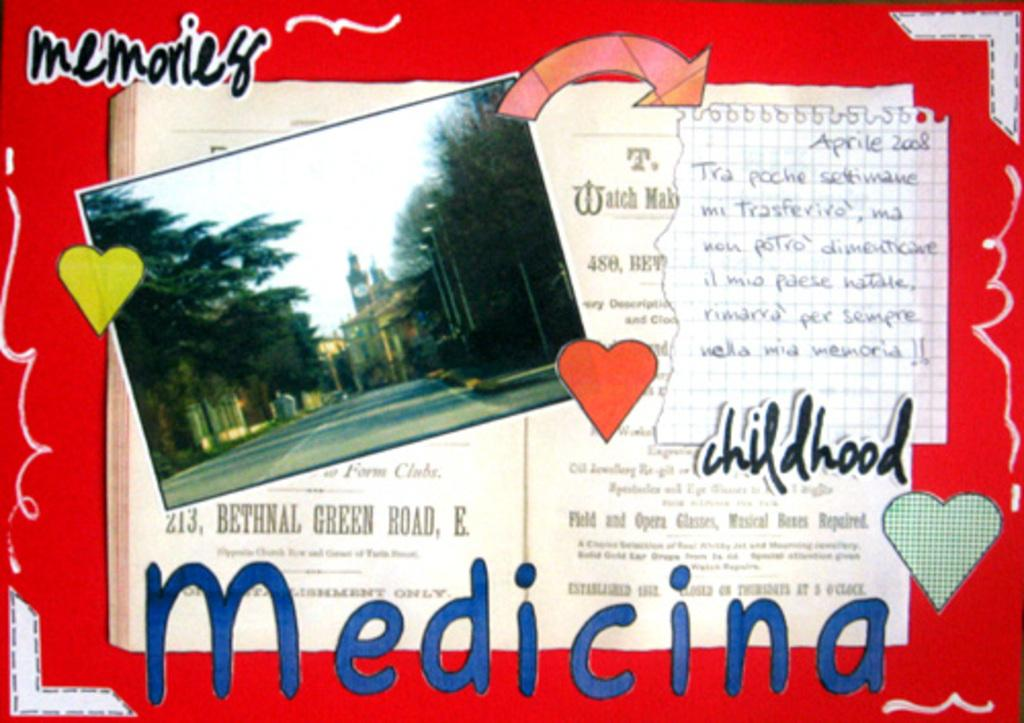<image>
Present a compact description of the photo's key features. A scrapbook page of childhood memories with a red background. 